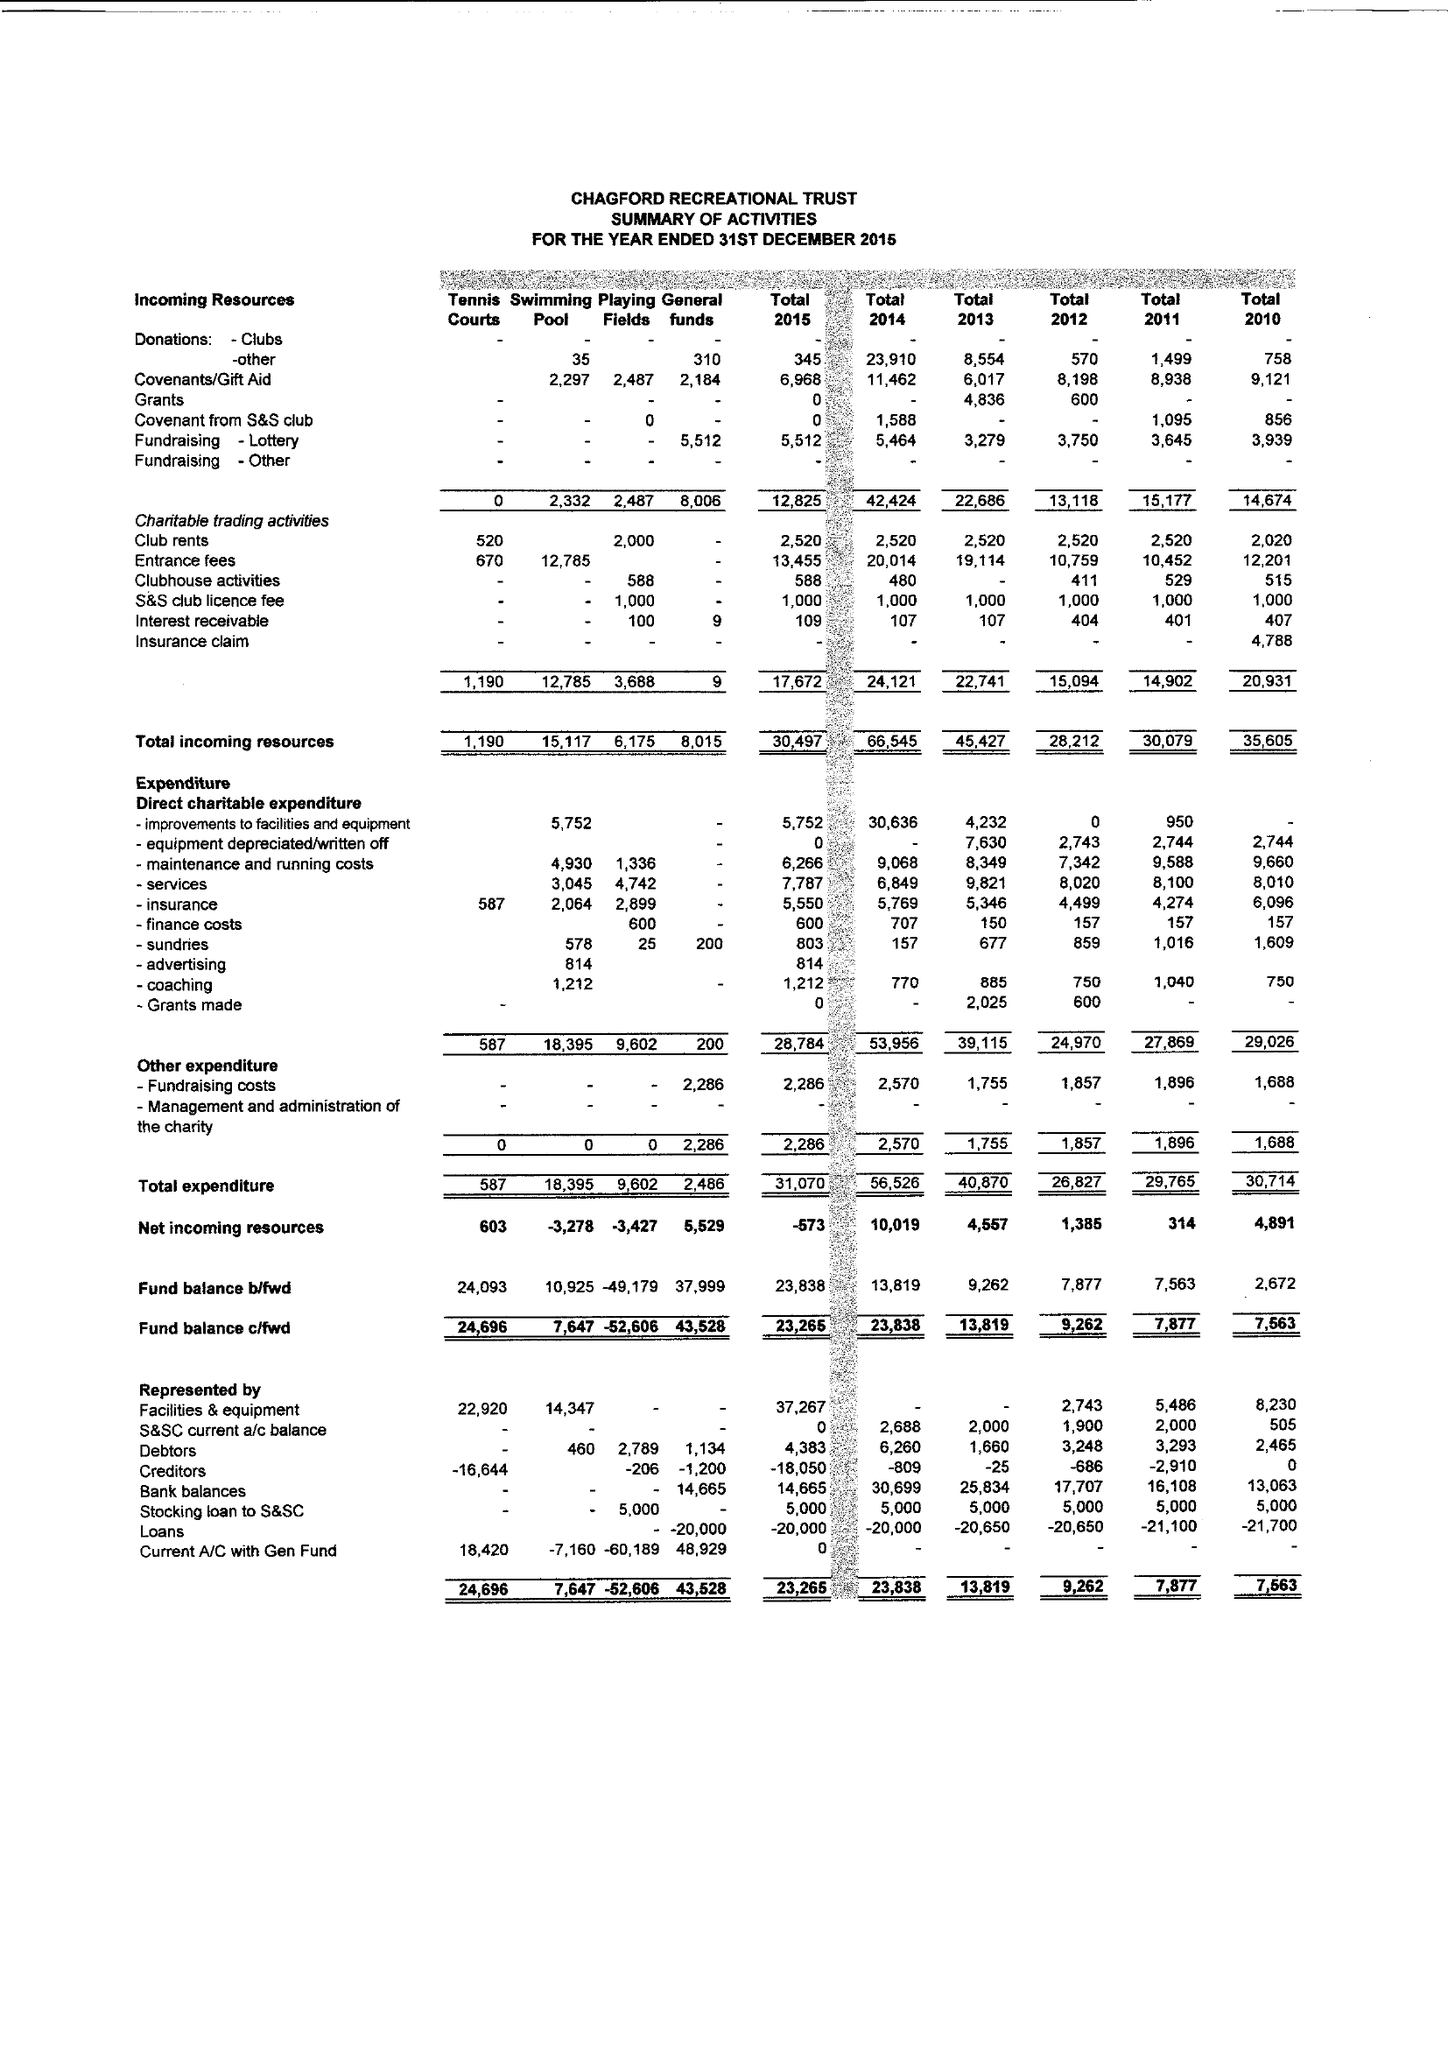What is the value for the charity_number?
Answer the question using a single word or phrase. 289574 